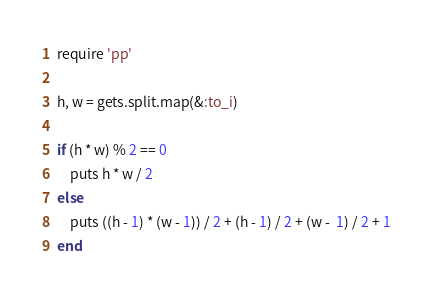<code> <loc_0><loc_0><loc_500><loc_500><_Ruby_>require 'pp'

h, w = gets.split.map(&:to_i)

if (h * w) % 2 == 0
    puts h * w / 2
else 
    puts ((h - 1) * (w - 1)) / 2 + (h - 1) / 2 + (w -  1) / 2 + 1
end
</code> 